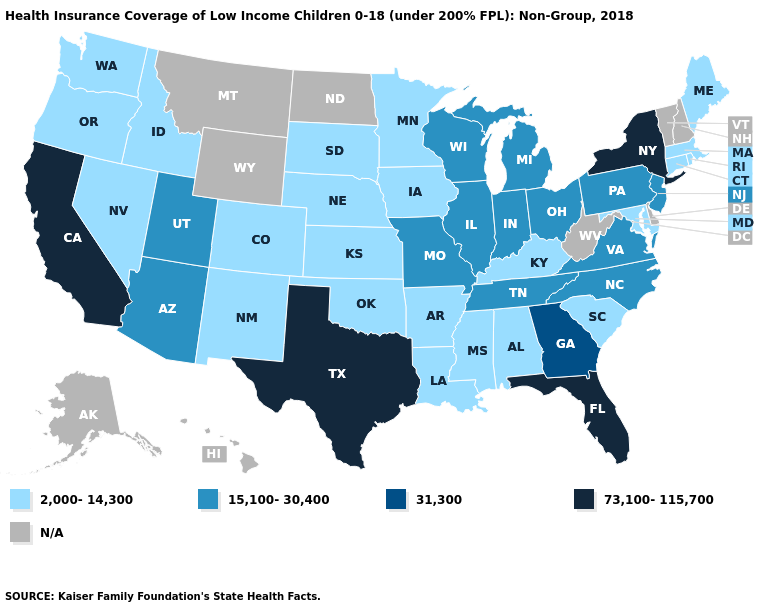Name the states that have a value in the range 31,300?
Quick response, please. Georgia. What is the highest value in the MidWest ?
Concise answer only. 15,100-30,400. What is the highest value in the South ?
Answer briefly. 73,100-115,700. Name the states that have a value in the range 2,000-14,300?
Concise answer only. Alabama, Arkansas, Colorado, Connecticut, Idaho, Iowa, Kansas, Kentucky, Louisiana, Maine, Maryland, Massachusetts, Minnesota, Mississippi, Nebraska, Nevada, New Mexico, Oklahoma, Oregon, Rhode Island, South Carolina, South Dakota, Washington. Does Rhode Island have the lowest value in the Northeast?
Answer briefly. Yes. Name the states that have a value in the range 31,300?
Write a very short answer. Georgia. Which states have the lowest value in the USA?
Answer briefly. Alabama, Arkansas, Colorado, Connecticut, Idaho, Iowa, Kansas, Kentucky, Louisiana, Maine, Maryland, Massachusetts, Minnesota, Mississippi, Nebraska, Nevada, New Mexico, Oklahoma, Oregon, Rhode Island, South Carolina, South Dakota, Washington. What is the highest value in states that border Tennessee?
Give a very brief answer. 31,300. Is the legend a continuous bar?
Answer briefly. No. Name the states that have a value in the range 2,000-14,300?
Answer briefly. Alabama, Arkansas, Colorado, Connecticut, Idaho, Iowa, Kansas, Kentucky, Louisiana, Maine, Maryland, Massachusetts, Minnesota, Mississippi, Nebraska, Nevada, New Mexico, Oklahoma, Oregon, Rhode Island, South Carolina, South Dakota, Washington. Does Minnesota have the highest value in the USA?
Write a very short answer. No. What is the highest value in the USA?
Keep it brief. 73,100-115,700. Does New Mexico have the highest value in the West?
Answer briefly. No. 